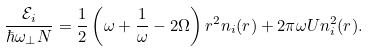Convert formula to latex. <formula><loc_0><loc_0><loc_500><loc_500>\frac { \mathcal { E } _ { i } } { \hbar { \omega } _ { \perp } N } = \frac { 1 } { 2 } \left ( \omega + \frac { 1 } { \omega } - 2 \Omega \right ) r ^ { 2 } n _ { i } ( { r } ) + 2 \pi \omega U n _ { i } ^ { 2 } ( { r } ) .</formula> 